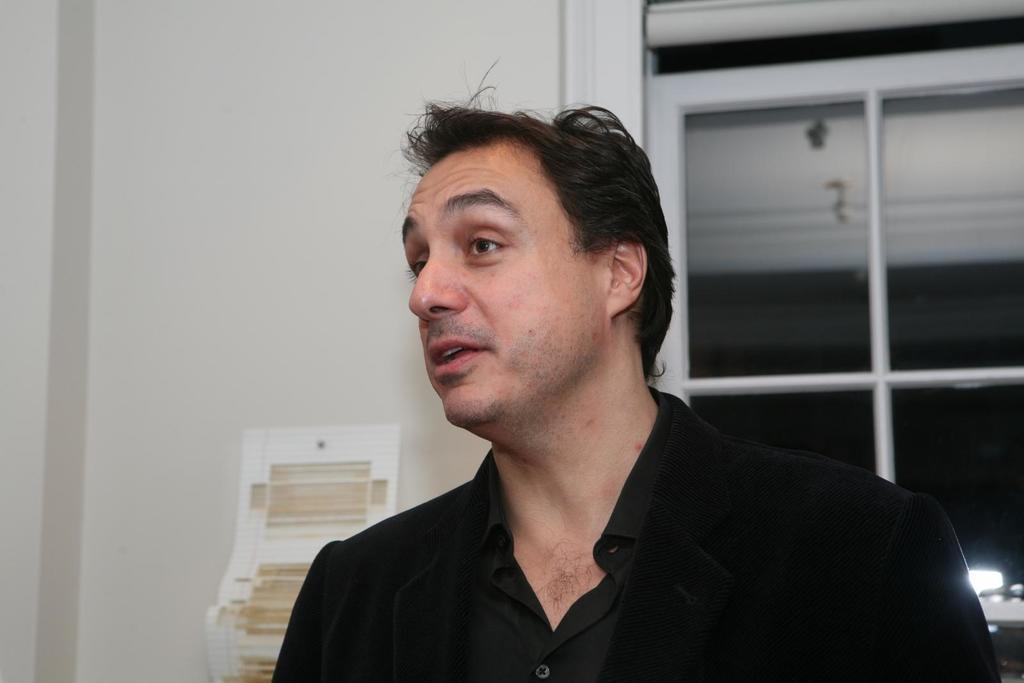Who is present in the image? There is a person in the image. What is the person wearing? The person is wearing a black shirt. What can be seen on the left side of the image? There is a white wall on the left side of the image. What is on the right side of the image? There is a window on the right side of the image. How many lizards are crawling on the person's shirt in the image? There are no lizards present in the image, and therefore no lizards are crawling on the person's shirt. What type of wing is visible on the person's back in the image? There is no wing visible on the person's back in the image. 